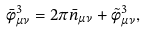Convert formula to latex. <formula><loc_0><loc_0><loc_500><loc_500>\bar { \phi } ^ { 3 } _ { \mu \nu } = 2 \pi \bar { n } _ { \mu \nu } + \tilde { \phi } ^ { 3 } _ { \mu \nu } ,</formula> 